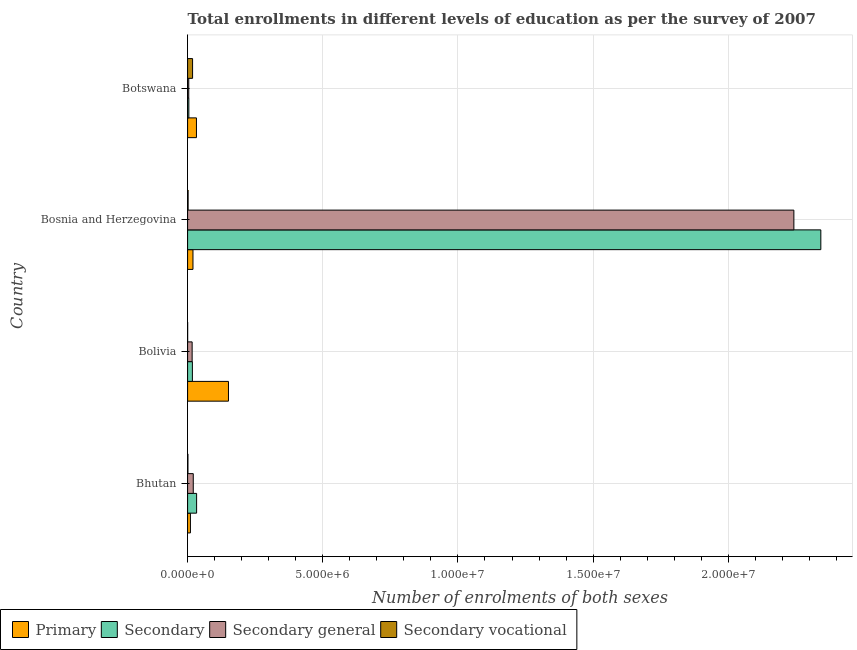How many groups of bars are there?
Make the answer very short. 4. Are the number of bars per tick equal to the number of legend labels?
Offer a terse response. Yes. What is the label of the 3rd group of bars from the top?
Your answer should be compact. Bolivia. In how many cases, is the number of bars for a given country not equal to the number of legend labels?
Offer a very short reply. 0. What is the number of enrolments in secondary general education in Bolivia?
Offer a terse response. 1.68e+05. Across all countries, what is the maximum number of enrolments in primary education?
Provide a succinct answer. 1.51e+06. Across all countries, what is the minimum number of enrolments in secondary education?
Offer a terse response. 4.62e+04. What is the total number of enrolments in secondary education in the graph?
Your answer should be compact. 2.40e+07. What is the difference between the number of enrolments in secondary vocational education in Bolivia and that in Bosnia and Herzegovina?
Your answer should be very brief. -1.73e+04. What is the difference between the number of enrolments in primary education in Bhutan and the number of enrolments in secondary education in Bosnia and Herzegovina?
Keep it short and to the point. -2.33e+07. What is the average number of enrolments in secondary education per country?
Ensure brevity in your answer.  6.00e+06. What is the difference between the number of enrolments in secondary vocational education and number of enrolments in primary education in Bosnia and Herzegovina?
Give a very brief answer. -1.80e+05. In how many countries, is the number of enrolments in secondary education greater than 23000000 ?
Keep it short and to the point. 1. What is the ratio of the number of enrolments in primary education in Bhutan to that in Bolivia?
Offer a terse response. 0.07. What is the difference between the highest and the second highest number of enrolments in secondary general education?
Keep it short and to the point. 2.22e+07. What is the difference between the highest and the lowest number of enrolments in secondary general education?
Ensure brevity in your answer.  2.24e+07. Is the sum of the number of enrolments in secondary education in Bhutan and Bosnia and Herzegovina greater than the maximum number of enrolments in secondary general education across all countries?
Your response must be concise. Yes. What does the 4th bar from the top in Bhutan represents?
Give a very brief answer. Primary. What does the 2nd bar from the bottom in Bolivia represents?
Your answer should be compact. Secondary. How many bars are there?
Keep it short and to the point. 16. Are all the bars in the graph horizontal?
Ensure brevity in your answer.  Yes. How many countries are there in the graph?
Your answer should be compact. 4. Does the graph contain any zero values?
Keep it short and to the point. No. How many legend labels are there?
Provide a succinct answer. 4. How are the legend labels stacked?
Provide a short and direct response. Horizontal. What is the title of the graph?
Make the answer very short. Total enrollments in different levels of education as per the survey of 2007. What is the label or title of the X-axis?
Offer a terse response. Number of enrolments of both sexes. What is the label or title of the Y-axis?
Provide a short and direct response. Country. What is the Number of enrolments of both sexes of Primary in Bhutan?
Offer a very short reply. 1.04e+05. What is the Number of enrolments of both sexes of Secondary in Bhutan?
Give a very brief answer. 3.33e+05. What is the Number of enrolments of both sexes of Secondary general in Bhutan?
Make the answer very short. 2.10e+05. What is the Number of enrolments of both sexes in Secondary vocational in Bhutan?
Your response must be concise. 1.26e+04. What is the Number of enrolments of both sexes in Primary in Bolivia?
Ensure brevity in your answer.  1.51e+06. What is the Number of enrolments of both sexes of Secondary in Bolivia?
Make the answer very short. 1.78e+05. What is the Number of enrolments of both sexes of Secondary general in Bolivia?
Provide a succinct answer. 1.68e+05. What is the Number of enrolments of both sexes in Secondary vocational in Bolivia?
Offer a very short reply. 1608. What is the Number of enrolments of both sexes of Primary in Bosnia and Herzegovina?
Keep it short and to the point. 1.99e+05. What is the Number of enrolments of both sexes in Secondary in Bosnia and Herzegovina?
Make the answer very short. 2.34e+07. What is the Number of enrolments of both sexes in Secondary general in Bosnia and Herzegovina?
Your answer should be compact. 2.24e+07. What is the Number of enrolments of both sexes in Secondary vocational in Bosnia and Herzegovina?
Offer a terse response. 1.89e+04. What is the Number of enrolments of both sexes in Primary in Botswana?
Offer a terse response. 3.28e+05. What is the Number of enrolments of both sexes of Secondary in Botswana?
Ensure brevity in your answer.  4.62e+04. What is the Number of enrolments of both sexes in Secondary general in Botswana?
Your answer should be compact. 4.29e+04. What is the Number of enrolments of both sexes in Secondary vocational in Botswana?
Give a very brief answer. 1.84e+05. Across all countries, what is the maximum Number of enrolments of both sexes in Primary?
Provide a short and direct response. 1.51e+06. Across all countries, what is the maximum Number of enrolments of both sexes in Secondary?
Ensure brevity in your answer.  2.34e+07. Across all countries, what is the maximum Number of enrolments of both sexes of Secondary general?
Ensure brevity in your answer.  2.24e+07. Across all countries, what is the maximum Number of enrolments of both sexes in Secondary vocational?
Make the answer very short. 1.84e+05. Across all countries, what is the minimum Number of enrolments of both sexes of Primary?
Your answer should be very brief. 1.04e+05. Across all countries, what is the minimum Number of enrolments of both sexes of Secondary?
Your answer should be compact. 4.62e+04. Across all countries, what is the minimum Number of enrolments of both sexes in Secondary general?
Offer a terse response. 4.29e+04. Across all countries, what is the minimum Number of enrolments of both sexes of Secondary vocational?
Your response must be concise. 1608. What is the total Number of enrolments of both sexes in Primary in the graph?
Provide a short and direct response. 2.14e+06. What is the total Number of enrolments of both sexes in Secondary in the graph?
Provide a short and direct response. 2.40e+07. What is the total Number of enrolments of both sexes of Secondary general in the graph?
Ensure brevity in your answer.  2.28e+07. What is the total Number of enrolments of both sexes of Secondary vocational in the graph?
Offer a terse response. 2.18e+05. What is the difference between the Number of enrolments of both sexes in Primary in Bhutan and that in Bolivia?
Your answer should be very brief. -1.41e+06. What is the difference between the Number of enrolments of both sexes in Secondary in Bhutan and that in Bolivia?
Provide a succinct answer. 1.56e+05. What is the difference between the Number of enrolments of both sexes of Secondary general in Bhutan and that in Bolivia?
Provide a short and direct response. 4.16e+04. What is the difference between the Number of enrolments of both sexes of Secondary vocational in Bhutan and that in Bolivia?
Your answer should be very brief. 1.10e+04. What is the difference between the Number of enrolments of both sexes in Primary in Bhutan and that in Bosnia and Herzegovina?
Offer a terse response. -9.43e+04. What is the difference between the Number of enrolments of both sexes of Secondary in Bhutan and that in Bosnia and Herzegovina?
Ensure brevity in your answer.  -2.31e+07. What is the difference between the Number of enrolments of both sexes of Secondary general in Bhutan and that in Bosnia and Herzegovina?
Your answer should be very brief. -2.22e+07. What is the difference between the Number of enrolments of both sexes of Secondary vocational in Bhutan and that in Bosnia and Herzegovina?
Your answer should be compact. -6290. What is the difference between the Number of enrolments of both sexes of Primary in Bhutan and that in Botswana?
Make the answer very short. -2.23e+05. What is the difference between the Number of enrolments of both sexes in Secondary in Bhutan and that in Botswana?
Provide a succinct answer. 2.87e+05. What is the difference between the Number of enrolments of both sexes in Secondary general in Bhutan and that in Botswana?
Provide a short and direct response. 1.67e+05. What is the difference between the Number of enrolments of both sexes of Secondary vocational in Bhutan and that in Botswana?
Offer a terse response. -1.72e+05. What is the difference between the Number of enrolments of both sexes in Primary in Bolivia and that in Bosnia and Herzegovina?
Offer a very short reply. 1.31e+06. What is the difference between the Number of enrolments of both sexes of Secondary in Bolivia and that in Bosnia and Herzegovina?
Provide a short and direct response. -2.32e+07. What is the difference between the Number of enrolments of both sexes in Secondary general in Bolivia and that in Bosnia and Herzegovina?
Your answer should be very brief. -2.23e+07. What is the difference between the Number of enrolments of both sexes of Secondary vocational in Bolivia and that in Bosnia and Herzegovina?
Your response must be concise. -1.73e+04. What is the difference between the Number of enrolments of both sexes of Primary in Bolivia and that in Botswana?
Ensure brevity in your answer.  1.18e+06. What is the difference between the Number of enrolments of both sexes of Secondary in Bolivia and that in Botswana?
Offer a very short reply. 1.31e+05. What is the difference between the Number of enrolments of both sexes of Secondary general in Bolivia and that in Botswana?
Offer a very short reply. 1.25e+05. What is the difference between the Number of enrolments of both sexes of Secondary vocational in Bolivia and that in Botswana?
Provide a succinct answer. -1.83e+05. What is the difference between the Number of enrolments of both sexes in Primary in Bosnia and Herzegovina and that in Botswana?
Make the answer very short. -1.29e+05. What is the difference between the Number of enrolments of both sexes of Secondary in Bosnia and Herzegovina and that in Botswana?
Make the answer very short. 2.34e+07. What is the difference between the Number of enrolments of both sexes in Secondary general in Bosnia and Herzegovina and that in Botswana?
Your answer should be compact. 2.24e+07. What is the difference between the Number of enrolments of both sexes in Secondary vocational in Bosnia and Herzegovina and that in Botswana?
Offer a very short reply. -1.66e+05. What is the difference between the Number of enrolments of both sexes of Primary in Bhutan and the Number of enrolments of both sexes of Secondary in Bolivia?
Keep it short and to the point. -7.31e+04. What is the difference between the Number of enrolments of both sexes in Primary in Bhutan and the Number of enrolments of both sexes in Secondary general in Bolivia?
Offer a terse response. -6.38e+04. What is the difference between the Number of enrolments of both sexes in Primary in Bhutan and the Number of enrolments of both sexes in Secondary vocational in Bolivia?
Your answer should be very brief. 1.03e+05. What is the difference between the Number of enrolments of both sexes in Secondary in Bhutan and the Number of enrolments of both sexes in Secondary general in Bolivia?
Provide a short and direct response. 1.65e+05. What is the difference between the Number of enrolments of both sexes of Secondary in Bhutan and the Number of enrolments of both sexes of Secondary vocational in Bolivia?
Provide a short and direct response. 3.32e+05. What is the difference between the Number of enrolments of both sexes of Secondary general in Bhutan and the Number of enrolments of both sexes of Secondary vocational in Bolivia?
Give a very brief answer. 2.08e+05. What is the difference between the Number of enrolments of both sexes in Primary in Bhutan and the Number of enrolments of both sexes in Secondary in Bosnia and Herzegovina?
Give a very brief answer. -2.33e+07. What is the difference between the Number of enrolments of both sexes of Primary in Bhutan and the Number of enrolments of both sexes of Secondary general in Bosnia and Herzegovina?
Ensure brevity in your answer.  -2.23e+07. What is the difference between the Number of enrolments of both sexes in Primary in Bhutan and the Number of enrolments of both sexes in Secondary vocational in Bosnia and Herzegovina?
Make the answer very short. 8.55e+04. What is the difference between the Number of enrolments of both sexes of Secondary in Bhutan and the Number of enrolments of both sexes of Secondary general in Bosnia and Herzegovina?
Your answer should be compact. -2.21e+07. What is the difference between the Number of enrolments of both sexes in Secondary in Bhutan and the Number of enrolments of both sexes in Secondary vocational in Bosnia and Herzegovina?
Your answer should be compact. 3.14e+05. What is the difference between the Number of enrolments of both sexes of Secondary general in Bhutan and the Number of enrolments of both sexes of Secondary vocational in Bosnia and Herzegovina?
Provide a short and direct response. 1.91e+05. What is the difference between the Number of enrolments of both sexes in Primary in Bhutan and the Number of enrolments of both sexes in Secondary in Botswana?
Provide a short and direct response. 5.83e+04. What is the difference between the Number of enrolments of both sexes in Primary in Bhutan and the Number of enrolments of both sexes in Secondary general in Botswana?
Offer a terse response. 6.15e+04. What is the difference between the Number of enrolments of both sexes in Primary in Bhutan and the Number of enrolments of both sexes in Secondary vocational in Botswana?
Your response must be concise. -8.00e+04. What is the difference between the Number of enrolments of both sexes of Secondary in Bhutan and the Number of enrolments of both sexes of Secondary general in Botswana?
Give a very brief answer. 2.90e+05. What is the difference between the Number of enrolments of both sexes in Secondary in Bhutan and the Number of enrolments of both sexes in Secondary vocational in Botswana?
Give a very brief answer. 1.49e+05. What is the difference between the Number of enrolments of both sexes in Secondary general in Bhutan and the Number of enrolments of both sexes in Secondary vocational in Botswana?
Give a very brief answer. 2.54e+04. What is the difference between the Number of enrolments of both sexes in Primary in Bolivia and the Number of enrolments of both sexes in Secondary in Bosnia and Herzegovina?
Make the answer very short. -2.19e+07. What is the difference between the Number of enrolments of both sexes of Primary in Bolivia and the Number of enrolments of both sexes of Secondary general in Bosnia and Herzegovina?
Provide a succinct answer. -2.09e+07. What is the difference between the Number of enrolments of both sexes of Primary in Bolivia and the Number of enrolments of both sexes of Secondary vocational in Bosnia and Herzegovina?
Provide a short and direct response. 1.49e+06. What is the difference between the Number of enrolments of both sexes in Secondary in Bolivia and the Number of enrolments of both sexes in Secondary general in Bosnia and Herzegovina?
Offer a terse response. -2.22e+07. What is the difference between the Number of enrolments of both sexes of Secondary in Bolivia and the Number of enrolments of both sexes of Secondary vocational in Bosnia and Herzegovina?
Your answer should be compact. 1.59e+05. What is the difference between the Number of enrolments of both sexes in Secondary general in Bolivia and the Number of enrolments of both sexes in Secondary vocational in Bosnia and Herzegovina?
Provide a succinct answer. 1.49e+05. What is the difference between the Number of enrolments of both sexes in Primary in Bolivia and the Number of enrolments of both sexes in Secondary in Botswana?
Provide a succinct answer. 1.47e+06. What is the difference between the Number of enrolments of both sexes of Primary in Bolivia and the Number of enrolments of both sexes of Secondary general in Botswana?
Give a very brief answer. 1.47e+06. What is the difference between the Number of enrolments of both sexes in Primary in Bolivia and the Number of enrolments of both sexes in Secondary vocational in Botswana?
Make the answer very short. 1.33e+06. What is the difference between the Number of enrolments of both sexes of Secondary in Bolivia and the Number of enrolments of both sexes of Secondary general in Botswana?
Your response must be concise. 1.35e+05. What is the difference between the Number of enrolments of both sexes of Secondary in Bolivia and the Number of enrolments of both sexes of Secondary vocational in Botswana?
Provide a succinct answer. -6819. What is the difference between the Number of enrolments of both sexes in Secondary general in Bolivia and the Number of enrolments of both sexes in Secondary vocational in Botswana?
Keep it short and to the point. -1.62e+04. What is the difference between the Number of enrolments of both sexes of Primary in Bosnia and Herzegovina and the Number of enrolments of both sexes of Secondary in Botswana?
Offer a very short reply. 1.53e+05. What is the difference between the Number of enrolments of both sexes of Primary in Bosnia and Herzegovina and the Number of enrolments of both sexes of Secondary general in Botswana?
Provide a short and direct response. 1.56e+05. What is the difference between the Number of enrolments of both sexes in Primary in Bosnia and Herzegovina and the Number of enrolments of both sexes in Secondary vocational in Botswana?
Your response must be concise. 1.44e+04. What is the difference between the Number of enrolments of both sexes of Secondary in Bosnia and Herzegovina and the Number of enrolments of both sexes of Secondary general in Botswana?
Your answer should be compact. 2.34e+07. What is the difference between the Number of enrolments of both sexes in Secondary in Bosnia and Herzegovina and the Number of enrolments of both sexes in Secondary vocational in Botswana?
Keep it short and to the point. 2.32e+07. What is the difference between the Number of enrolments of both sexes in Secondary general in Bosnia and Herzegovina and the Number of enrolments of both sexes in Secondary vocational in Botswana?
Your answer should be very brief. 2.22e+07. What is the average Number of enrolments of both sexes of Primary per country?
Your response must be concise. 5.36e+05. What is the average Number of enrolments of both sexes of Secondary per country?
Provide a succinct answer. 6.00e+06. What is the average Number of enrolments of both sexes of Secondary general per country?
Give a very brief answer. 5.71e+06. What is the average Number of enrolments of both sexes in Secondary vocational per country?
Make the answer very short. 5.44e+04. What is the difference between the Number of enrolments of both sexes of Primary and Number of enrolments of both sexes of Secondary in Bhutan?
Make the answer very short. -2.29e+05. What is the difference between the Number of enrolments of both sexes in Primary and Number of enrolments of both sexes in Secondary general in Bhutan?
Keep it short and to the point. -1.05e+05. What is the difference between the Number of enrolments of both sexes in Primary and Number of enrolments of both sexes in Secondary vocational in Bhutan?
Give a very brief answer. 9.18e+04. What is the difference between the Number of enrolments of both sexes in Secondary and Number of enrolments of both sexes in Secondary general in Bhutan?
Provide a succinct answer. 1.23e+05. What is the difference between the Number of enrolments of both sexes in Secondary and Number of enrolments of both sexes in Secondary vocational in Bhutan?
Ensure brevity in your answer.  3.21e+05. What is the difference between the Number of enrolments of both sexes of Secondary general and Number of enrolments of both sexes of Secondary vocational in Bhutan?
Keep it short and to the point. 1.97e+05. What is the difference between the Number of enrolments of both sexes in Primary and Number of enrolments of both sexes in Secondary in Bolivia?
Provide a succinct answer. 1.33e+06. What is the difference between the Number of enrolments of both sexes of Primary and Number of enrolments of both sexes of Secondary general in Bolivia?
Ensure brevity in your answer.  1.34e+06. What is the difference between the Number of enrolments of both sexes in Primary and Number of enrolments of both sexes in Secondary vocational in Bolivia?
Provide a short and direct response. 1.51e+06. What is the difference between the Number of enrolments of both sexes of Secondary and Number of enrolments of both sexes of Secondary general in Bolivia?
Give a very brief answer. 9395. What is the difference between the Number of enrolments of both sexes in Secondary and Number of enrolments of both sexes in Secondary vocational in Bolivia?
Offer a very short reply. 1.76e+05. What is the difference between the Number of enrolments of both sexes in Secondary general and Number of enrolments of both sexes in Secondary vocational in Bolivia?
Your answer should be compact. 1.67e+05. What is the difference between the Number of enrolments of both sexes in Primary and Number of enrolments of both sexes in Secondary in Bosnia and Herzegovina?
Your response must be concise. -2.32e+07. What is the difference between the Number of enrolments of both sexes of Primary and Number of enrolments of both sexes of Secondary general in Bosnia and Herzegovina?
Make the answer very short. -2.22e+07. What is the difference between the Number of enrolments of both sexes in Primary and Number of enrolments of both sexes in Secondary vocational in Bosnia and Herzegovina?
Offer a terse response. 1.80e+05. What is the difference between the Number of enrolments of both sexes in Secondary and Number of enrolments of both sexes in Secondary general in Bosnia and Herzegovina?
Give a very brief answer. 9.97e+05. What is the difference between the Number of enrolments of both sexes of Secondary and Number of enrolments of both sexes of Secondary vocational in Bosnia and Herzegovina?
Your answer should be very brief. 2.34e+07. What is the difference between the Number of enrolments of both sexes in Secondary general and Number of enrolments of both sexes in Secondary vocational in Bosnia and Herzegovina?
Your answer should be very brief. 2.24e+07. What is the difference between the Number of enrolments of both sexes of Primary and Number of enrolments of both sexes of Secondary in Botswana?
Provide a short and direct response. 2.81e+05. What is the difference between the Number of enrolments of both sexes in Primary and Number of enrolments of both sexes in Secondary general in Botswana?
Keep it short and to the point. 2.85e+05. What is the difference between the Number of enrolments of both sexes in Primary and Number of enrolments of both sexes in Secondary vocational in Botswana?
Offer a very short reply. 1.43e+05. What is the difference between the Number of enrolments of both sexes of Secondary and Number of enrolments of both sexes of Secondary general in Botswana?
Provide a succinct answer. 3230. What is the difference between the Number of enrolments of both sexes of Secondary and Number of enrolments of both sexes of Secondary vocational in Botswana?
Give a very brief answer. -1.38e+05. What is the difference between the Number of enrolments of both sexes in Secondary general and Number of enrolments of both sexes in Secondary vocational in Botswana?
Offer a very short reply. -1.41e+05. What is the ratio of the Number of enrolments of both sexes in Primary in Bhutan to that in Bolivia?
Offer a very short reply. 0.07. What is the ratio of the Number of enrolments of both sexes in Secondary in Bhutan to that in Bolivia?
Your answer should be very brief. 1.88. What is the ratio of the Number of enrolments of both sexes of Secondary general in Bhutan to that in Bolivia?
Make the answer very short. 1.25. What is the ratio of the Number of enrolments of both sexes of Secondary vocational in Bhutan to that in Bolivia?
Your answer should be compact. 7.85. What is the ratio of the Number of enrolments of both sexes in Primary in Bhutan to that in Bosnia and Herzegovina?
Provide a succinct answer. 0.53. What is the ratio of the Number of enrolments of both sexes in Secondary in Bhutan to that in Bosnia and Herzegovina?
Your answer should be compact. 0.01. What is the ratio of the Number of enrolments of both sexes in Secondary general in Bhutan to that in Bosnia and Herzegovina?
Your answer should be very brief. 0.01. What is the ratio of the Number of enrolments of both sexes of Secondary vocational in Bhutan to that in Bosnia and Herzegovina?
Your answer should be compact. 0.67. What is the ratio of the Number of enrolments of both sexes in Primary in Bhutan to that in Botswana?
Provide a succinct answer. 0.32. What is the ratio of the Number of enrolments of both sexes in Secondary in Bhutan to that in Botswana?
Keep it short and to the point. 7.22. What is the ratio of the Number of enrolments of both sexes of Secondary general in Bhutan to that in Botswana?
Offer a very short reply. 4.89. What is the ratio of the Number of enrolments of both sexes of Secondary vocational in Bhutan to that in Botswana?
Make the answer very short. 0.07. What is the ratio of the Number of enrolments of both sexes in Primary in Bolivia to that in Bosnia and Herzegovina?
Give a very brief answer. 7.61. What is the ratio of the Number of enrolments of both sexes of Secondary in Bolivia to that in Bosnia and Herzegovina?
Make the answer very short. 0.01. What is the ratio of the Number of enrolments of both sexes of Secondary general in Bolivia to that in Bosnia and Herzegovina?
Offer a terse response. 0.01. What is the ratio of the Number of enrolments of both sexes of Secondary vocational in Bolivia to that in Bosnia and Herzegovina?
Offer a very short reply. 0.09. What is the ratio of the Number of enrolments of both sexes in Primary in Bolivia to that in Botswana?
Give a very brief answer. 4.62. What is the ratio of the Number of enrolments of both sexes in Secondary in Bolivia to that in Botswana?
Offer a very short reply. 3.85. What is the ratio of the Number of enrolments of both sexes in Secondary general in Bolivia to that in Botswana?
Make the answer very short. 3.92. What is the ratio of the Number of enrolments of both sexes of Secondary vocational in Bolivia to that in Botswana?
Give a very brief answer. 0.01. What is the ratio of the Number of enrolments of both sexes in Primary in Bosnia and Herzegovina to that in Botswana?
Offer a terse response. 0.61. What is the ratio of the Number of enrolments of both sexes in Secondary in Bosnia and Herzegovina to that in Botswana?
Ensure brevity in your answer.  507.31. What is the ratio of the Number of enrolments of both sexes of Secondary general in Bosnia and Herzegovina to that in Botswana?
Give a very brief answer. 522.24. What is the ratio of the Number of enrolments of both sexes of Secondary vocational in Bosnia and Herzegovina to that in Botswana?
Ensure brevity in your answer.  0.1. What is the difference between the highest and the second highest Number of enrolments of both sexes in Primary?
Your response must be concise. 1.18e+06. What is the difference between the highest and the second highest Number of enrolments of both sexes of Secondary?
Offer a very short reply. 2.31e+07. What is the difference between the highest and the second highest Number of enrolments of both sexes in Secondary general?
Offer a terse response. 2.22e+07. What is the difference between the highest and the second highest Number of enrolments of both sexes in Secondary vocational?
Provide a short and direct response. 1.66e+05. What is the difference between the highest and the lowest Number of enrolments of both sexes of Primary?
Offer a very short reply. 1.41e+06. What is the difference between the highest and the lowest Number of enrolments of both sexes of Secondary?
Your answer should be very brief. 2.34e+07. What is the difference between the highest and the lowest Number of enrolments of both sexes of Secondary general?
Your answer should be very brief. 2.24e+07. What is the difference between the highest and the lowest Number of enrolments of both sexes of Secondary vocational?
Ensure brevity in your answer.  1.83e+05. 